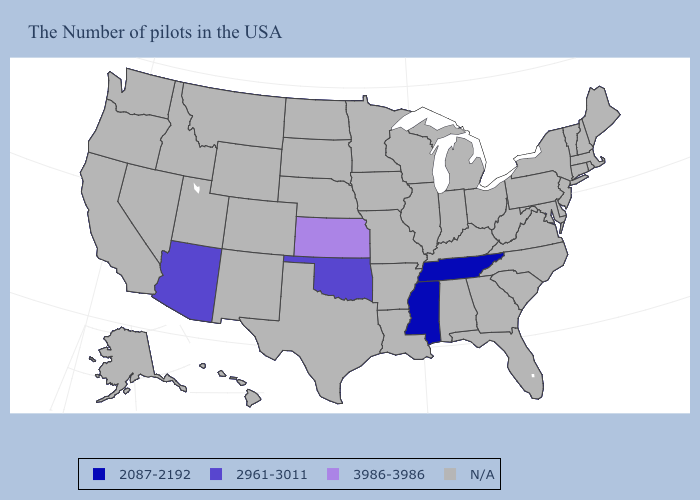What is the value of West Virginia?
Short answer required. N/A. Does Mississippi have the lowest value in the USA?
Quick response, please. Yes. Which states have the highest value in the USA?
Keep it brief. Kansas. Name the states that have a value in the range 3986-3986?
Short answer required. Kansas. Which states have the lowest value in the USA?
Keep it brief. Tennessee, Mississippi. What is the value of South Carolina?
Concise answer only. N/A. What is the lowest value in the West?
Be succinct. 2961-3011. Which states have the lowest value in the USA?
Quick response, please. Tennessee, Mississippi. Does the first symbol in the legend represent the smallest category?
Short answer required. Yes. What is the highest value in the MidWest ?
Quick response, please. 3986-3986. 